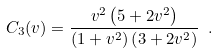<formula> <loc_0><loc_0><loc_500><loc_500>C _ { 3 } ( v ) = \frac { v ^ { 2 } \left ( 5 + 2 v ^ { 2 } \right ) } { \left ( 1 + v ^ { 2 } \right ) \left ( 3 + 2 v ^ { 2 } \right ) } \ .</formula> 